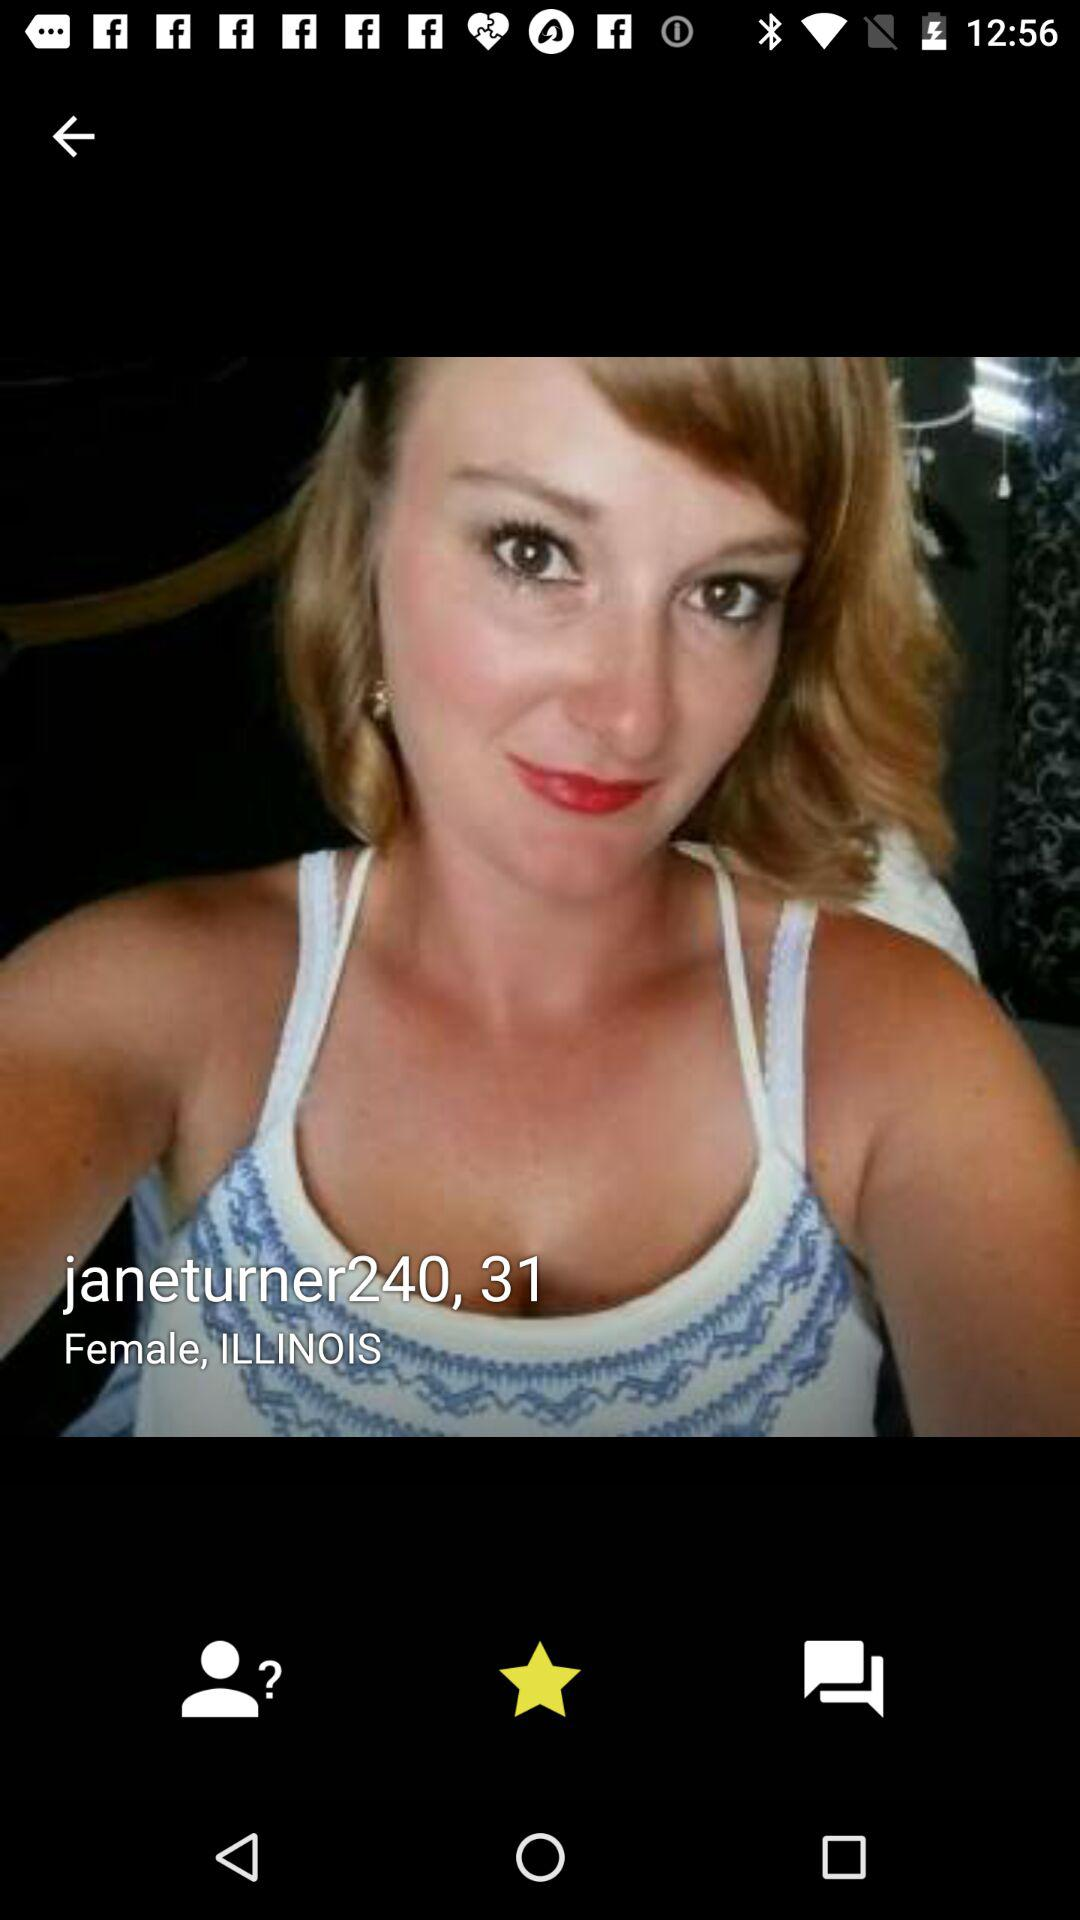What is the gender? The gender is female. 